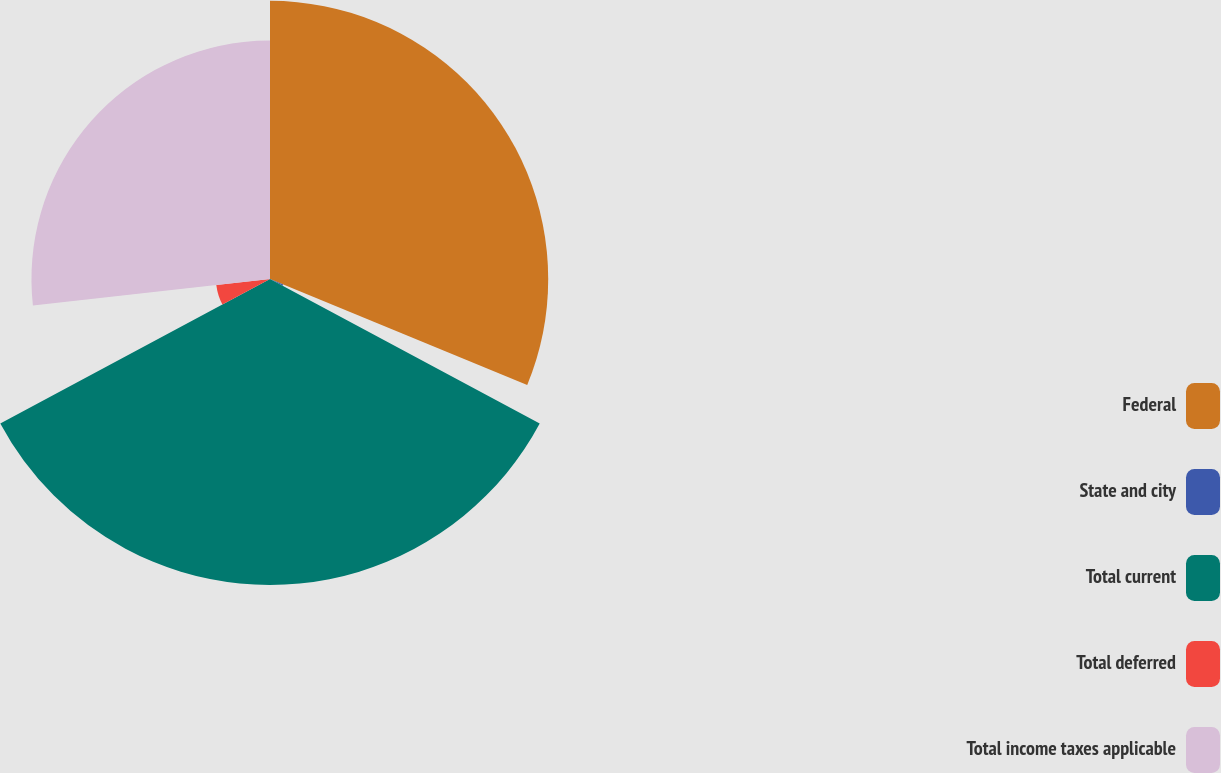Convert chart. <chart><loc_0><loc_0><loc_500><loc_500><pie_chart><fcel>Federal<fcel>State and city<fcel>Total current<fcel>Total deferred<fcel>Total income taxes applicable<nl><fcel>31.22%<fcel>1.61%<fcel>34.34%<fcel>6.06%<fcel>26.77%<nl></chart> 